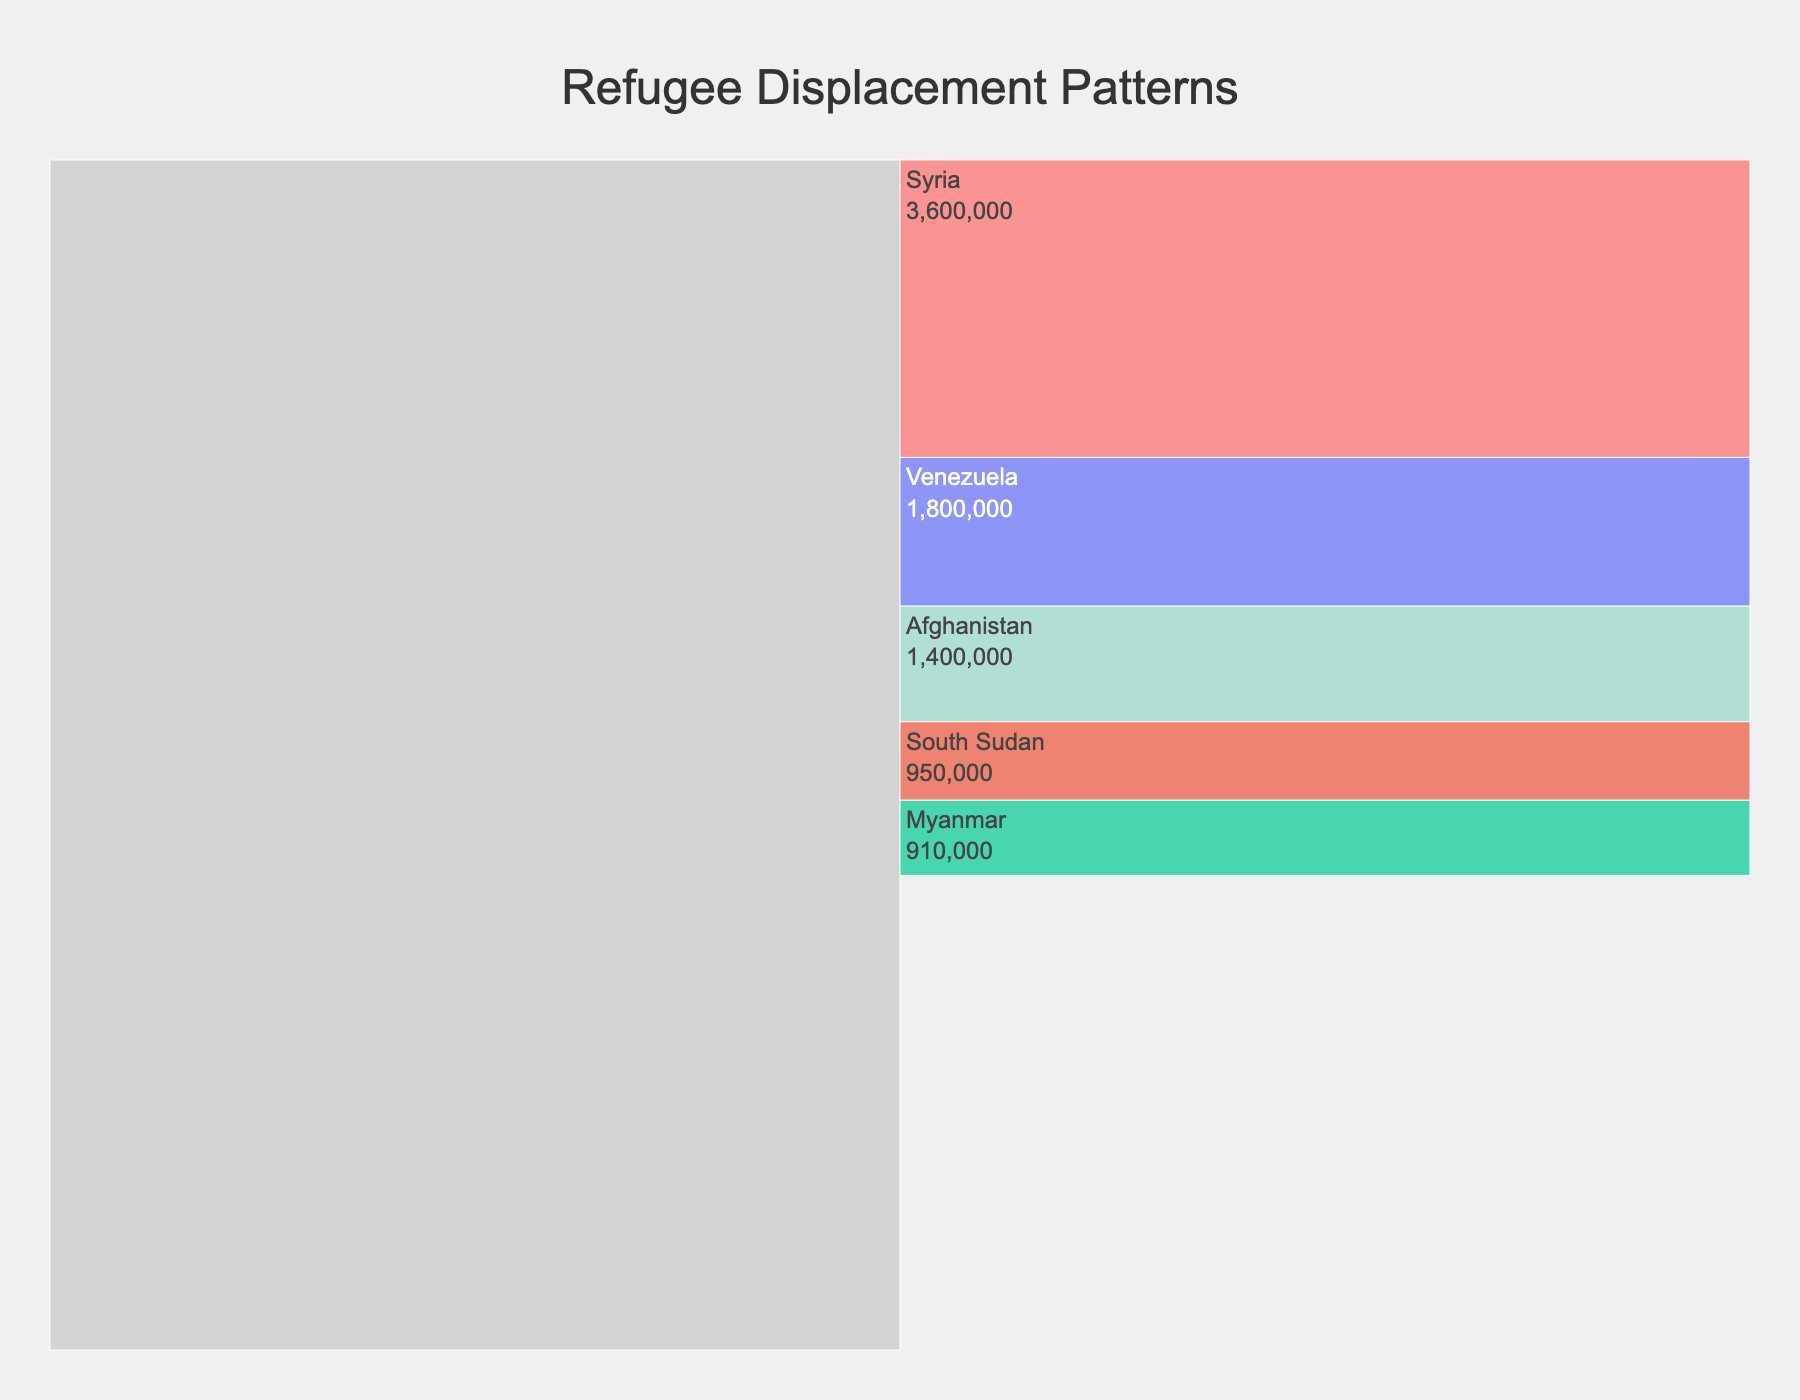Who has the highest number of refugees according to the chart? From the chart, Syria has the highest number of refugees due to Turkish numbers alone (3,600,000). Combined with the rest, it's clear they top the list.
Answer: Syria What's the total number of Syrian refugees going to Turkey and Lebanon? Adding the number of refugees going to Turkey (3,600,000) and Lebanon (850,000): 3,600,000 + 850,000 gives 4,450,000.
Answer: 4,450,000 How does the number of South Sudanese refugees in Uganda compare to those in Sudan? According to the chart, South Sudanese refugees in Uganda are 950,000, while those in Sudan are 740,000. Hence, Uganda has more South Sudanese refugees.
Answer: Uganda has more Which destination does Venezuela send the most refugees to? Looking at the chart, Venezuela sends the most refugees to Colombia with 1,800,000.
Answer: Colombia What is the combined total number of all Afghan refugees? Summing the numbers for all destinations from Afghanistan: Pakistan (1,400,000), Iran (780,000), and Germany (180,000). 1,400,000 + 780,000 + 180,000 = 2,360,000.
Answer: 2,360,000 Compare the number of Myanmar refugees in Malaysia to those in Thailand. The chart shows 150,000 in Malaysia and 95,000 in Thailand. Hence, there are more in Malaysia.
Answer: More in Malaysia What proportion of South Sudanese refugees are in Ethiopia compared to the total South Sudanese refugees? The total South Sudanese refugees are 950,000 in Uganda + 740,000 in Sudan + 380,000 in Ethiopia = 2,070,000. The proportion in Ethiopia: 380,000 / 2,070,000 ≈ 18.36%.
Answer: Approximately 18.36% How many more Venezuelan refugees are in Colombia compared to Peru? The number of Venezuelan refugees in Colombia is 1,800,000, and in Peru, it is 830,000. So, the difference is 1,800,000 - 830,000 = 970,000.
Answer: 970,000 more In terms of receiving refugees from Syria, how does Germany rank compared to other destinations? Germany receives 620,000 Syrian refugees, which is fewer than Turkey and Lebanon but more than Jordan. Ranking: 3rd.
Answer: 3rd 